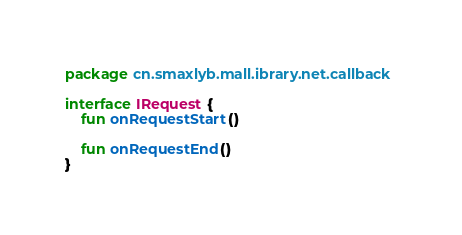Convert code to text. <code><loc_0><loc_0><loc_500><loc_500><_Kotlin_>package cn.smaxlyb.mall.ibrary.net.callback

interface IRequest {
    fun onRequestStart()

    fun onRequestEnd()
}</code> 